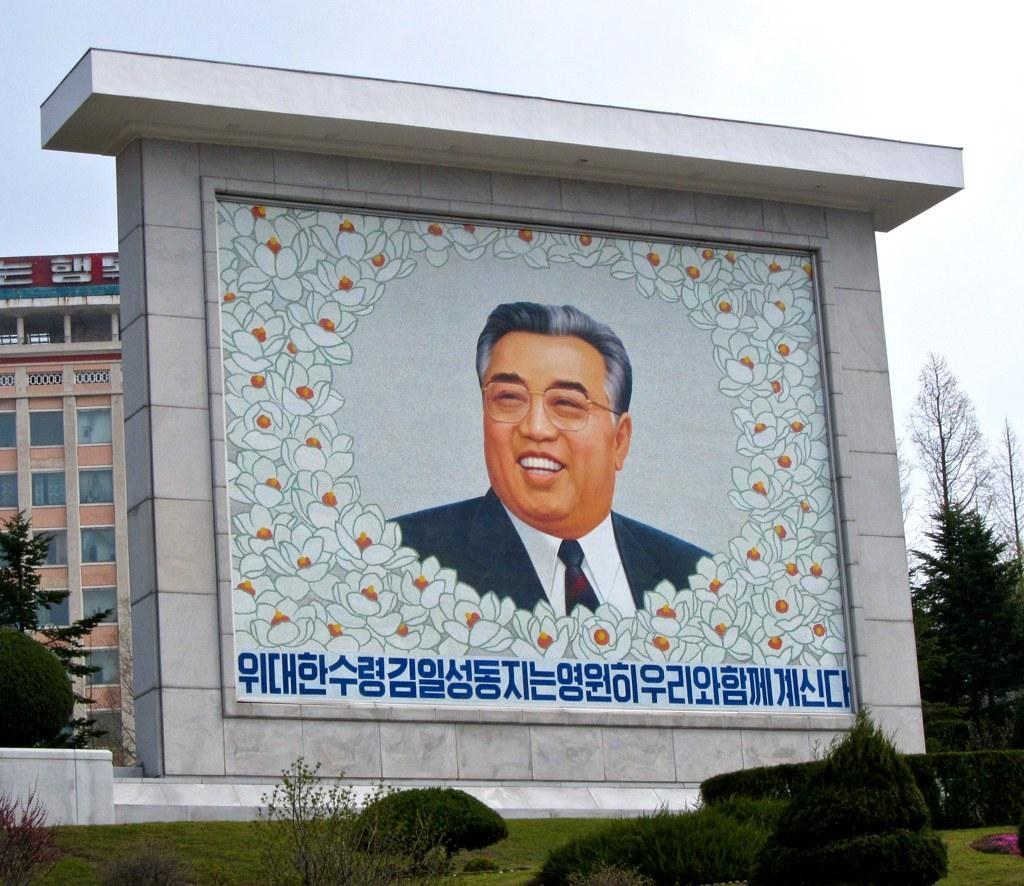What type of structure is visible in the image? There is a building in the image. What feature can be seen on the building? The building has windows. What other objects are present in the image? There are trees and a person's photo on the wall. What is the color of the sky in the image? The sky appears to be white in color. Can you see the fish swimming in the sky in the image? No, there are no fish visible in the image, and the sky is white in color. 